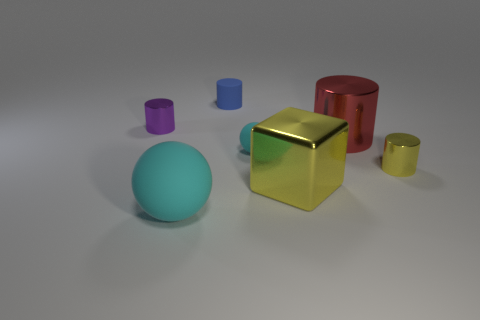Subtract all red cylinders. Subtract all purple spheres. How many cylinders are left? 3 Add 2 blue spheres. How many objects exist? 9 Subtract all spheres. How many objects are left? 5 Subtract 1 cyan balls. How many objects are left? 6 Subtract all large red metal things. Subtract all yellow blocks. How many objects are left? 5 Add 3 big cyan rubber things. How many big cyan rubber things are left? 4 Add 6 big brown shiny cylinders. How many big brown shiny cylinders exist? 6 